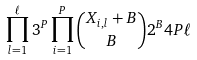Convert formula to latex. <formula><loc_0><loc_0><loc_500><loc_500>\prod _ { l = 1 } ^ { \ell } 3 ^ { P } \prod _ { i = 1 } ^ { P } { X _ { i , l } + B \choose B } 2 ^ { B } 4 P \ell</formula> 